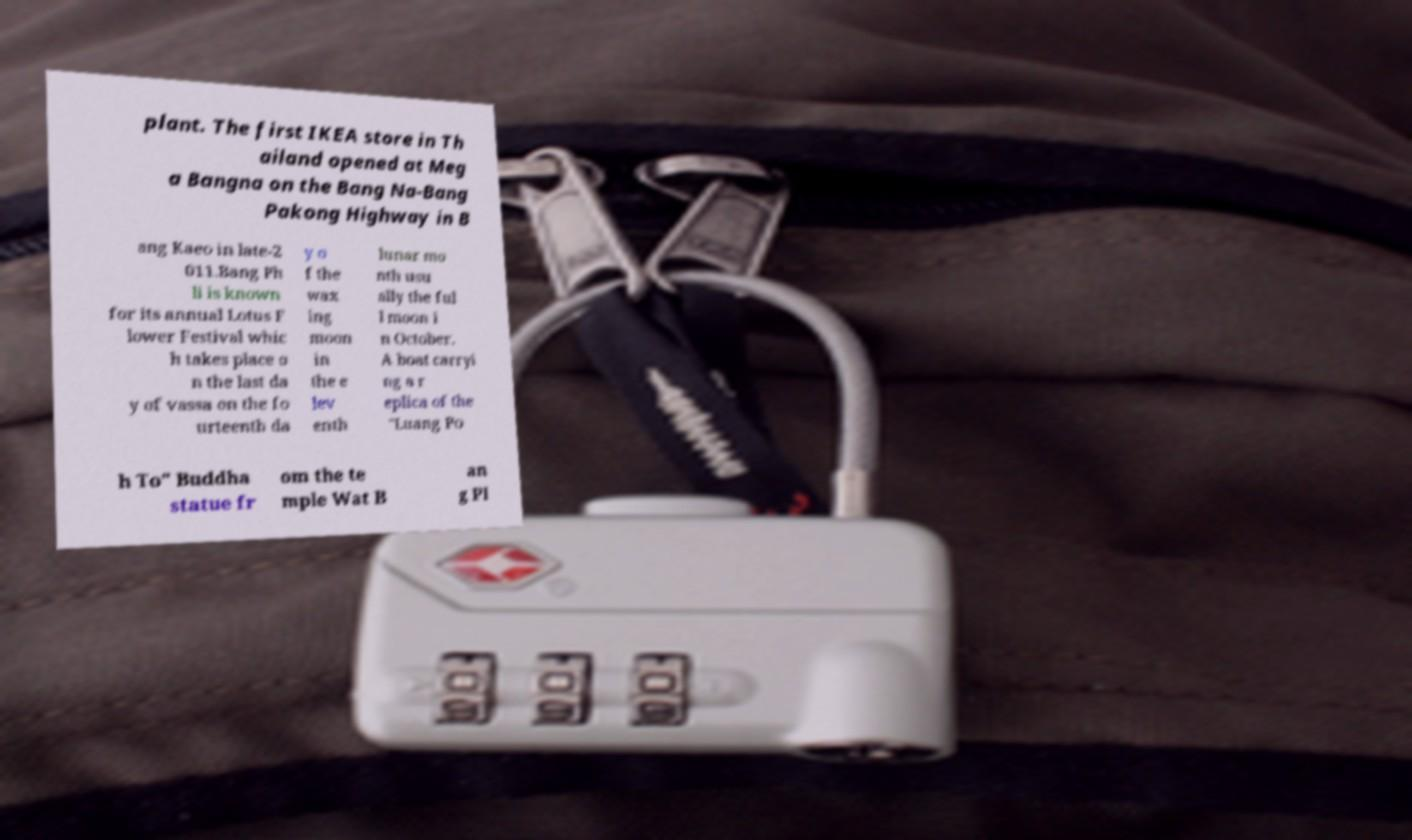For documentation purposes, I need the text within this image transcribed. Could you provide that? plant. The first IKEA store in Th ailand opened at Meg a Bangna on the Bang Na-Bang Pakong Highway in B ang Kaeo in late-2 011.Bang Ph li is known for its annual Lotus F lower Festival whic h takes place o n the last da y of vassa on the fo urteenth da y o f the wax ing moon in the e lev enth lunar mo nth usu ally the ful l moon i n October. A boat carryi ng a r eplica of the "Luang Po h To" Buddha statue fr om the te mple Wat B an g Pl 